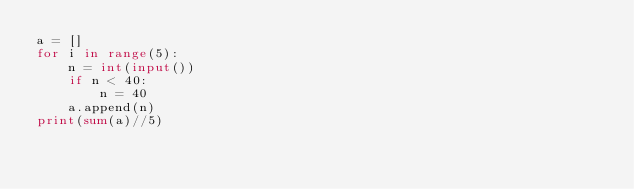<code> <loc_0><loc_0><loc_500><loc_500><_Python_>a = []
for i in range(5):
    n = int(input())
    if n < 40:
        n = 40
    a.append(n)
print(sum(a)//5)
</code> 